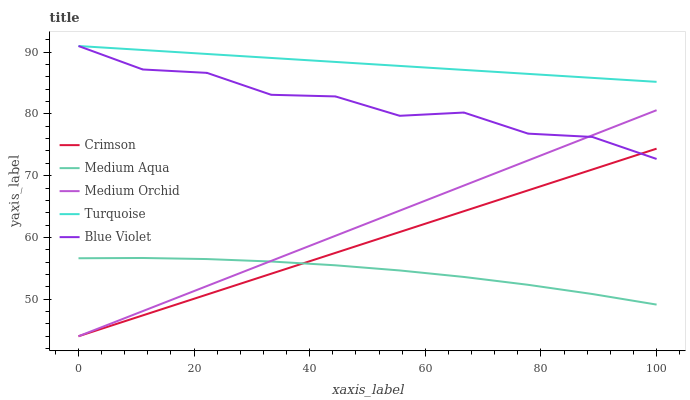Does Medium Aqua have the minimum area under the curve?
Answer yes or no. Yes. Does Turquoise have the maximum area under the curve?
Answer yes or no. Yes. Does Medium Orchid have the minimum area under the curve?
Answer yes or no. No. Does Medium Orchid have the maximum area under the curve?
Answer yes or no. No. Is Crimson the smoothest?
Answer yes or no. Yes. Is Blue Violet the roughest?
Answer yes or no. Yes. Is Turquoise the smoothest?
Answer yes or no. No. Is Turquoise the roughest?
Answer yes or no. No. Does Crimson have the lowest value?
Answer yes or no. Yes. Does Turquoise have the lowest value?
Answer yes or no. No. Does Blue Violet have the highest value?
Answer yes or no. Yes. Does Medium Orchid have the highest value?
Answer yes or no. No. Is Medium Aqua less than Blue Violet?
Answer yes or no. Yes. Is Turquoise greater than Medium Aqua?
Answer yes or no. Yes. Does Medium Aqua intersect Medium Orchid?
Answer yes or no. Yes. Is Medium Aqua less than Medium Orchid?
Answer yes or no. No. Is Medium Aqua greater than Medium Orchid?
Answer yes or no. No. Does Medium Aqua intersect Blue Violet?
Answer yes or no. No. 